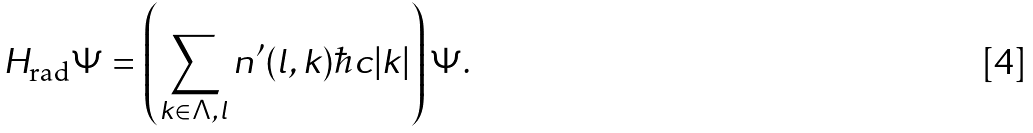<formula> <loc_0><loc_0><loc_500><loc_500>H _ { \text {rad} } \Psi = \left ( \sum _ { k \in \Lambda , l } n ^ { \prime } ( l , k ) \hbar { c } | k | \right ) \Psi .</formula> 